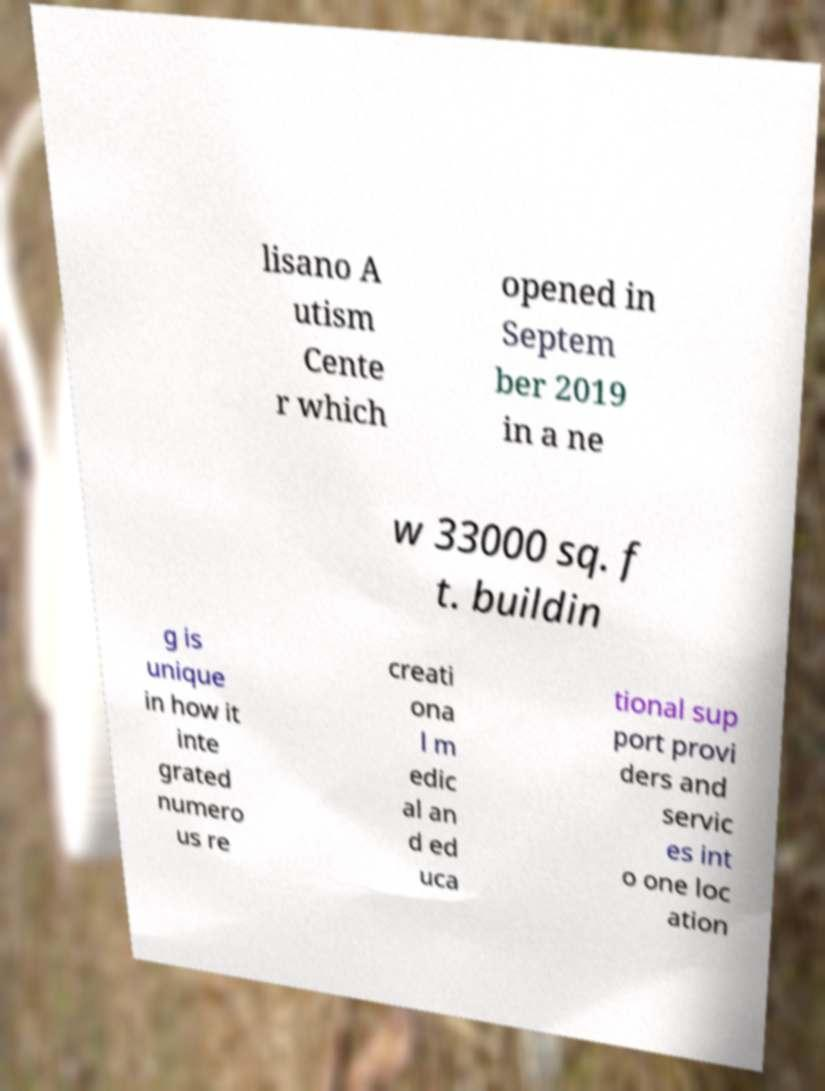For documentation purposes, I need the text within this image transcribed. Could you provide that? lisano A utism Cente r which opened in Septem ber 2019 in a ne w 33000 sq. f t. buildin g is unique in how it inte grated numero us re creati ona l m edic al an d ed uca tional sup port provi ders and servic es int o one loc ation 